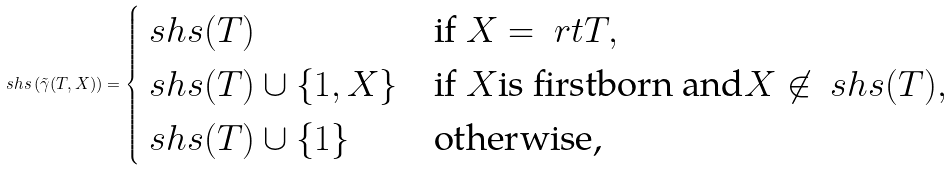<formula> <loc_0><loc_0><loc_500><loc_500>\ s h s \left ( \tilde { \gamma } ( T , X ) \right ) = \begin{cases} \ s h s ( T ) & \text {if } X = \ r t { T } , \\ \ s h s ( T ) \cup \{ 1 , X \} & \text {if } X \text {is firstborn and} X \not \in \ s h s ( T ) , \\ \ s h s ( T ) \cup \{ 1 \} & \text {otherwise,} \end{cases}</formula> 